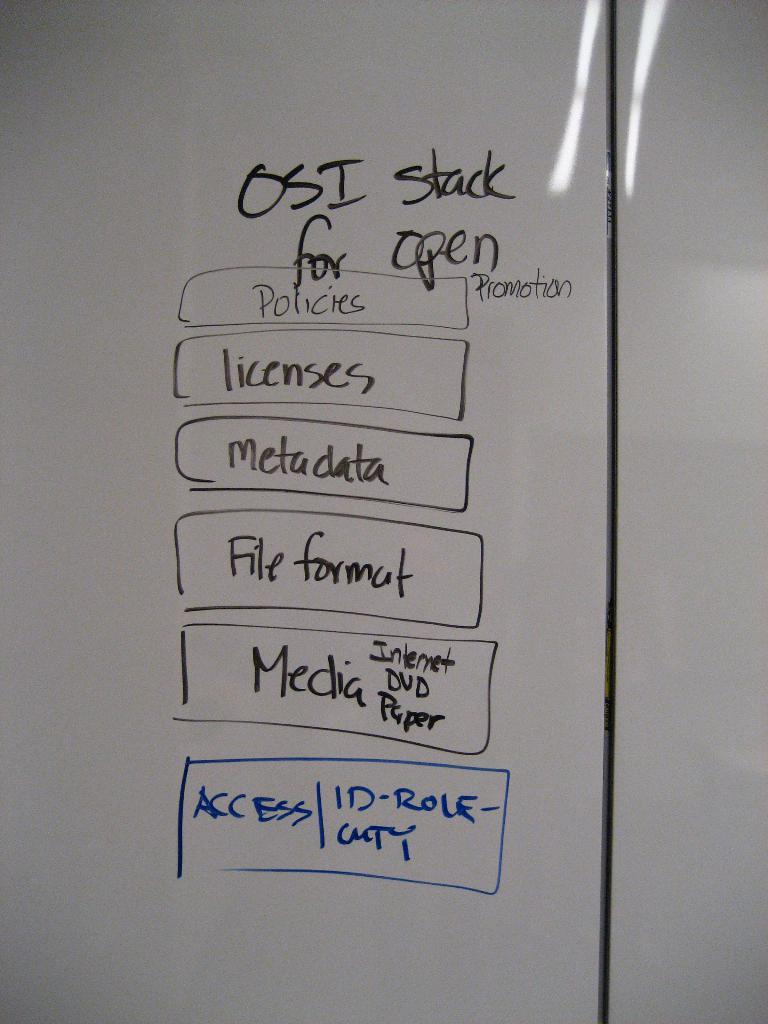<image>
Relay a brief, clear account of the picture shown. A white board with a dry erase marker list labeled OSI stack for open. 